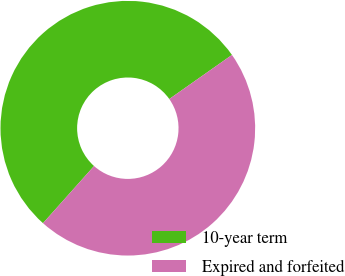<chart> <loc_0><loc_0><loc_500><loc_500><pie_chart><fcel>10-year term<fcel>Expired and forfeited<nl><fcel>53.64%<fcel>46.36%<nl></chart> 